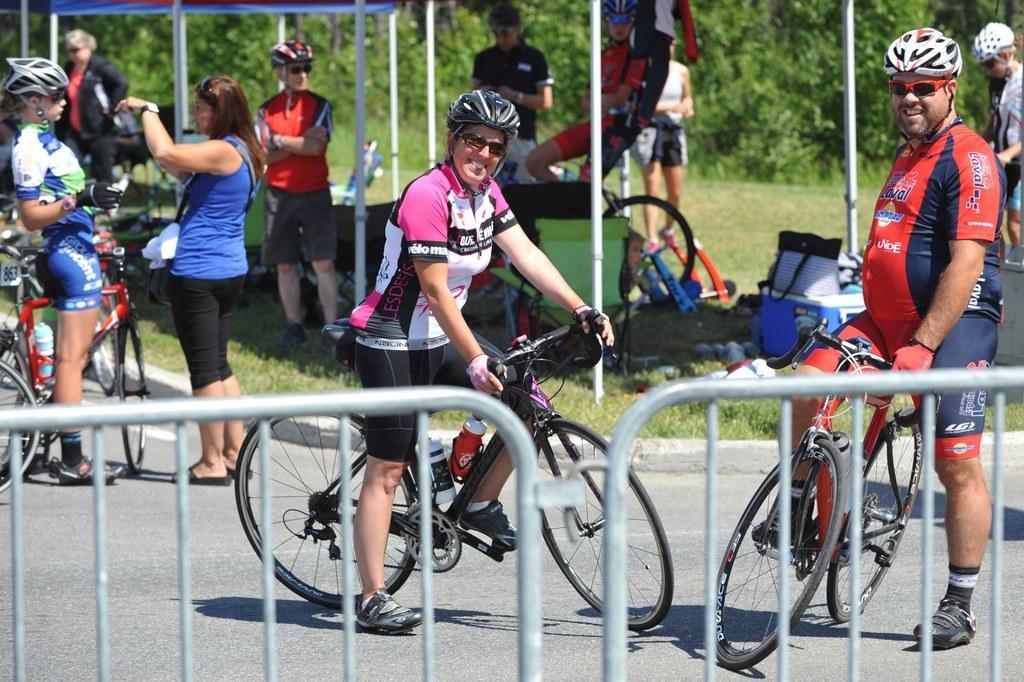Describe this image in one or two sentences. In this picture are two members riding a bicycle wearing helmet and spectacles. in the background there are some people standing here under the tent. There are some poles and trees here. 